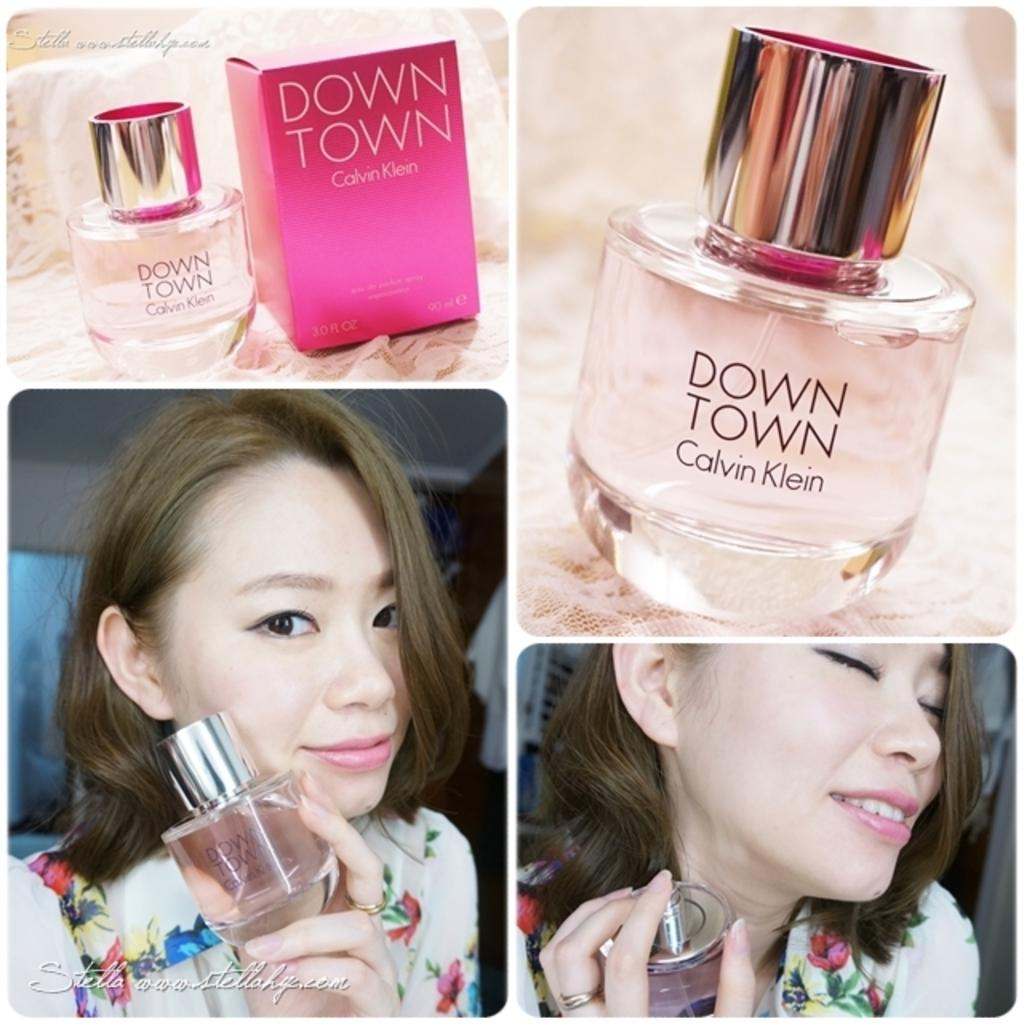<image>
Give a short and clear explanation of the subsequent image. A woman poses with a bottle of Down Town perfume by Calvin Klein. 